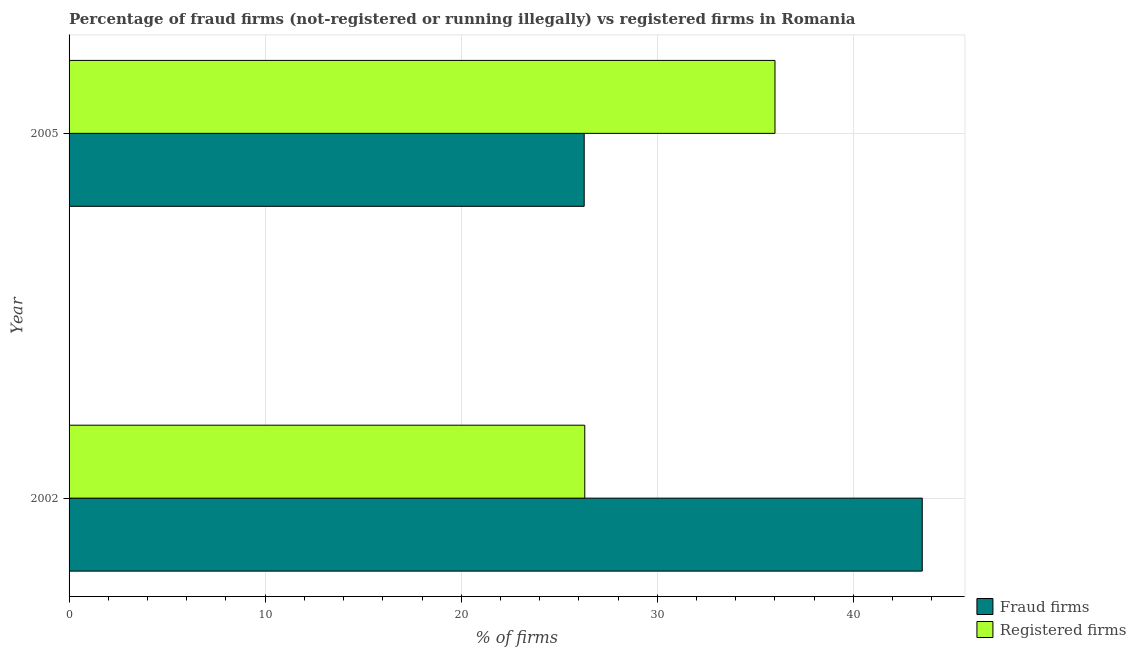How many different coloured bars are there?
Your answer should be very brief. 2. How many groups of bars are there?
Offer a terse response. 2. Are the number of bars per tick equal to the number of legend labels?
Provide a succinct answer. Yes. Are the number of bars on each tick of the Y-axis equal?
Your response must be concise. Yes. How many bars are there on the 1st tick from the top?
Make the answer very short. 2. What is the label of the 1st group of bars from the top?
Provide a short and direct response. 2005. In how many cases, is the number of bars for a given year not equal to the number of legend labels?
Ensure brevity in your answer.  0. What is the percentage of fraud firms in 2005?
Offer a very short reply. 26.27. Across all years, what is the maximum percentage of fraud firms?
Provide a succinct answer. 43.51. Across all years, what is the minimum percentage of fraud firms?
Your answer should be very brief. 26.27. In which year was the percentage of fraud firms maximum?
Provide a succinct answer. 2002. In which year was the percentage of fraud firms minimum?
Your answer should be very brief. 2005. What is the total percentage of fraud firms in the graph?
Provide a succinct answer. 69.78. What is the difference between the percentage of fraud firms in 2002 and that in 2005?
Provide a succinct answer. 17.24. What is the difference between the percentage of fraud firms in 2002 and the percentage of registered firms in 2005?
Keep it short and to the point. 7.51. What is the average percentage of fraud firms per year?
Your response must be concise. 34.89. In the year 2005, what is the difference between the percentage of fraud firms and percentage of registered firms?
Give a very brief answer. -9.73. What is the ratio of the percentage of fraud firms in 2002 to that in 2005?
Offer a very short reply. 1.66. Is the percentage of fraud firms in 2002 less than that in 2005?
Make the answer very short. No. Is the difference between the percentage of fraud firms in 2002 and 2005 greater than the difference between the percentage of registered firms in 2002 and 2005?
Make the answer very short. Yes. What does the 2nd bar from the top in 2002 represents?
Your answer should be very brief. Fraud firms. What does the 1st bar from the bottom in 2005 represents?
Your response must be concise. Fraud firms. Are all the bars in the graph horizontal?
Offer a terse response. Yes. Are the values on the major ticks of X-axis written in scientific E-notation?
Provide a short and direct response. No. Where does the legend appear in the graph?
Your answer should be very brief. Bottom right. How many legend labels are there?
Your answer should be very brief. 2. What is the title of the graph?
Your answer should be very brief. Percentage of fraud firms (not-registered or running illegally) vs registered firms in Romania. Does "Official aid received" appear as one of the legend labels in the graph?
Provide a succinct answer. No. What is the label or title of the X-axis?
Ensure brevity in your answer.  % of firms. What is the % of firms of Fraud firms in 2002?
Ensure brevity in your answer.  43.51. What is the % of firms of Registered firms in 2002?
Provide a succinct answer. 26.3. What is the % of firms in Fraud firms in 2005?
Your answer should be compact. 26.27. Across all years, what is the maximum % of firms in Fraud firms?
Make the answer very short. 43.51. Across all years, what is the minimum % of firms of Fraud firms?
Provide a succinct answer. 26.27. Across all years, what is the minimum % of firms of Registered firms?
Your answer should be compact. 26.3. What is the total % of firms of Fraud firms in the graph?
Your response must be concise. 69.78. What is the total % of firms of Registered firms in the graph?
Your answer should be compact. 62.3. What is the difference between the % of firms of Fraud firms in 2002 and that in 2005?
Your answer should be compact. 17.24. What is the difference between the % of firms in Registered firms in 2002 and that in 2005?
Ensure brevity in your answer.  -9.7. What is the difference between the % of firms in Fraud firms in 2002 and the % of firms in Registered firms in 2005?
Give a very brief answer. 7.51. What is the average % of firms in Fraud firms per year?
Provide a succinct answer. 34.89. What is the average % of firms of Registered firms per year?
Your answer should be compact. 31.15. In the year 2002, what is the difference between the % of firms in Fraud firms and % of firms in Registered firms?
Provide a succinct answer. 17.21. In the year 2005, what is the difference between the % of firms in Fraud firms and % of firms in Registered firms?
Provide a short and direct response. -9.73. What is the ratio of the % of firms in Fraud firms in 2002 to that in 2005?
Offer a very short reply. 1.66. What is the ratio of the % of firms of Registered firms in 2002 to that in 2005?
Your answer should be very brief. 0.73. What is the difference between the highest and the second highest % of firms in Fraud firms?
Provide a succinct answer. 17.24. What is the difference between the highest and the second highest % of firms of Registered firms?
Your answer should be very brief. 9.7. What is the difference between the highest and the lowest % of firms of Fraud firms?
Make the answer very short. 17.24. What is the difference between the highest and the lowest % of firms in Registered firms?
Your answer should be compact. 9.7. 